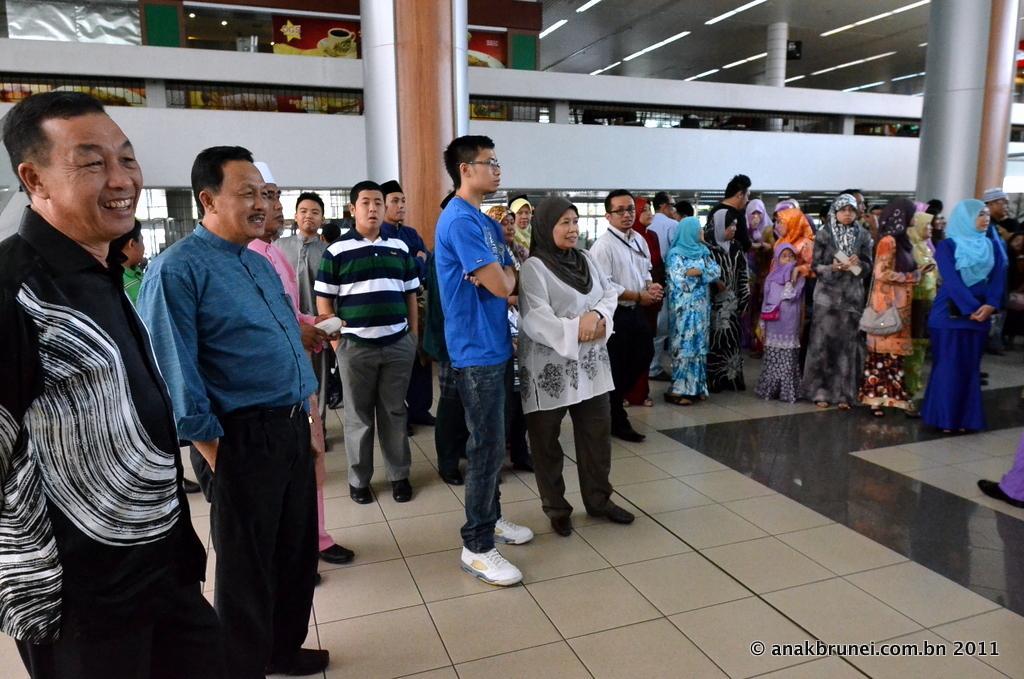Describe this image in one or two sentences. In this image I can see group of people standing. The person in front wearing blue shirt, gray color pant. Background I can see a board attached to the glass wall and I can see few pillars in gray color. 